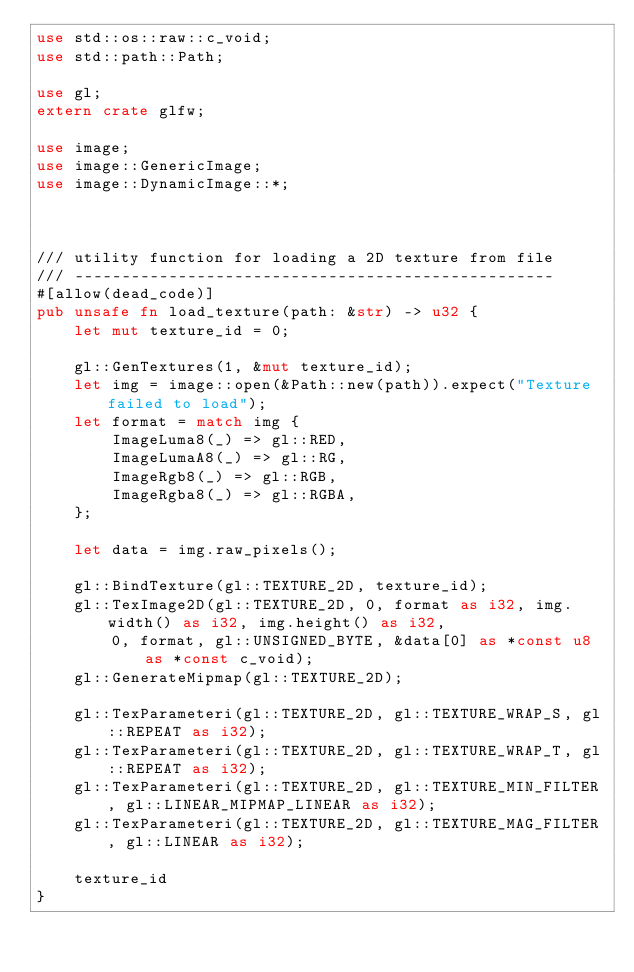Convert code to text. <code><loc_0><loc_0><loc_500><loc_500><_Rust_>use std::os::raw::c_void;
use std::path::Path;

use gl;
extern crate glfw;

use image;
use image::GenericImage;
use image::DynamicImage::*;



/// utility function for loading a 2D texture from file
/// ---------------------------------------------------
#[allow(dead_code)]
pub unsafe fn load_texture(path: &str) -> u32 {
    let mut texture_id = 0;

    gl::GenTextures(1, &mut texture_id);
    let img = image::open(&Path::new(path)).expect("Texture failed to load");
    let format = match img {
        ImageLuma8(_) => gl::RED,
        ImageLumaA8(_) => gl::RG,
        ImageRgb8(_) => gl::RGB,
        ImageRgba8(_) => gl::RGBA,
    };

    let data = img.raw_pixels();

    gl::BindTexture(gl::TEXTURE_2D, texture_id);
    gl::TexImage2D(gl::TEXTURE_2D, 0, format as i32, img.width() as i32, img.height() as i32,
        0, format, gl::UNSIGNED_BYTE, &data[0] as *const u8 as *const c_void);
    gl::GenerateMipmap(gl::TEXTURE_2D);

    gl::TexParameteri(gl::TEXTURE_2D, gl::TEXTURE_WRAP_S, gl::REPEAT as i32);
    gl::TexParameteri(gl::TEXTURE_2D, gl::TEXTURE_WRAP_T, gl::REPEAT as i32);
    gl::TexParameteri(gl::TEXTURE_2D, gl::TEXTURE_MIN_FILTER, gl::LINEAR_MIPMAP_LINEAR as i32);
    gl::TexParameteri(gl::TEXTURE_2D, gl::TEXTURE_MAG_FILTER, gl::LINEAR as i32);

    texture_id
}
</code> 